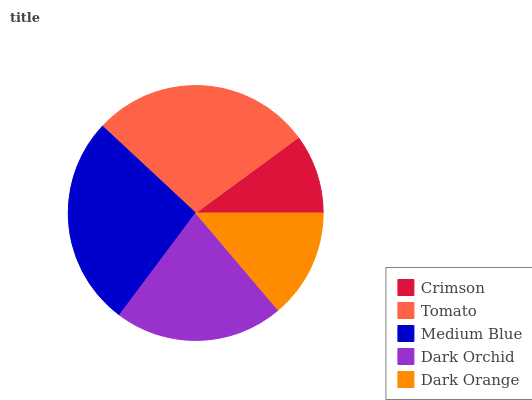Is Crimson the minimum?
Answer yes or no. Yes. Is Tomato the maximum?
Answer yes or no. Yes. Is Medium Blue the minimum?
Answer yes or no. No. Is Medium Blue the maximum?
Answer yes or no. No. Is Tomato greater than Medium Blue?
Answer yes or no. Yes. Is Medium Blue less than Tomato?
Answer yes or no. Yes. Is Medium Blue greater than Tomato?
Answer yes or no. No. Is Tomato less than Medium Blue?
Answer yes or no. No. Is Dark Orchid the high median?
Answer yes or no. Yes. Is Dark Orchid the low median?
Answer yes or no. Yes. Is Crimson the high median?
Answer yes or no. No. Is Dark Orange the low median?
Answer yes or no. No. 